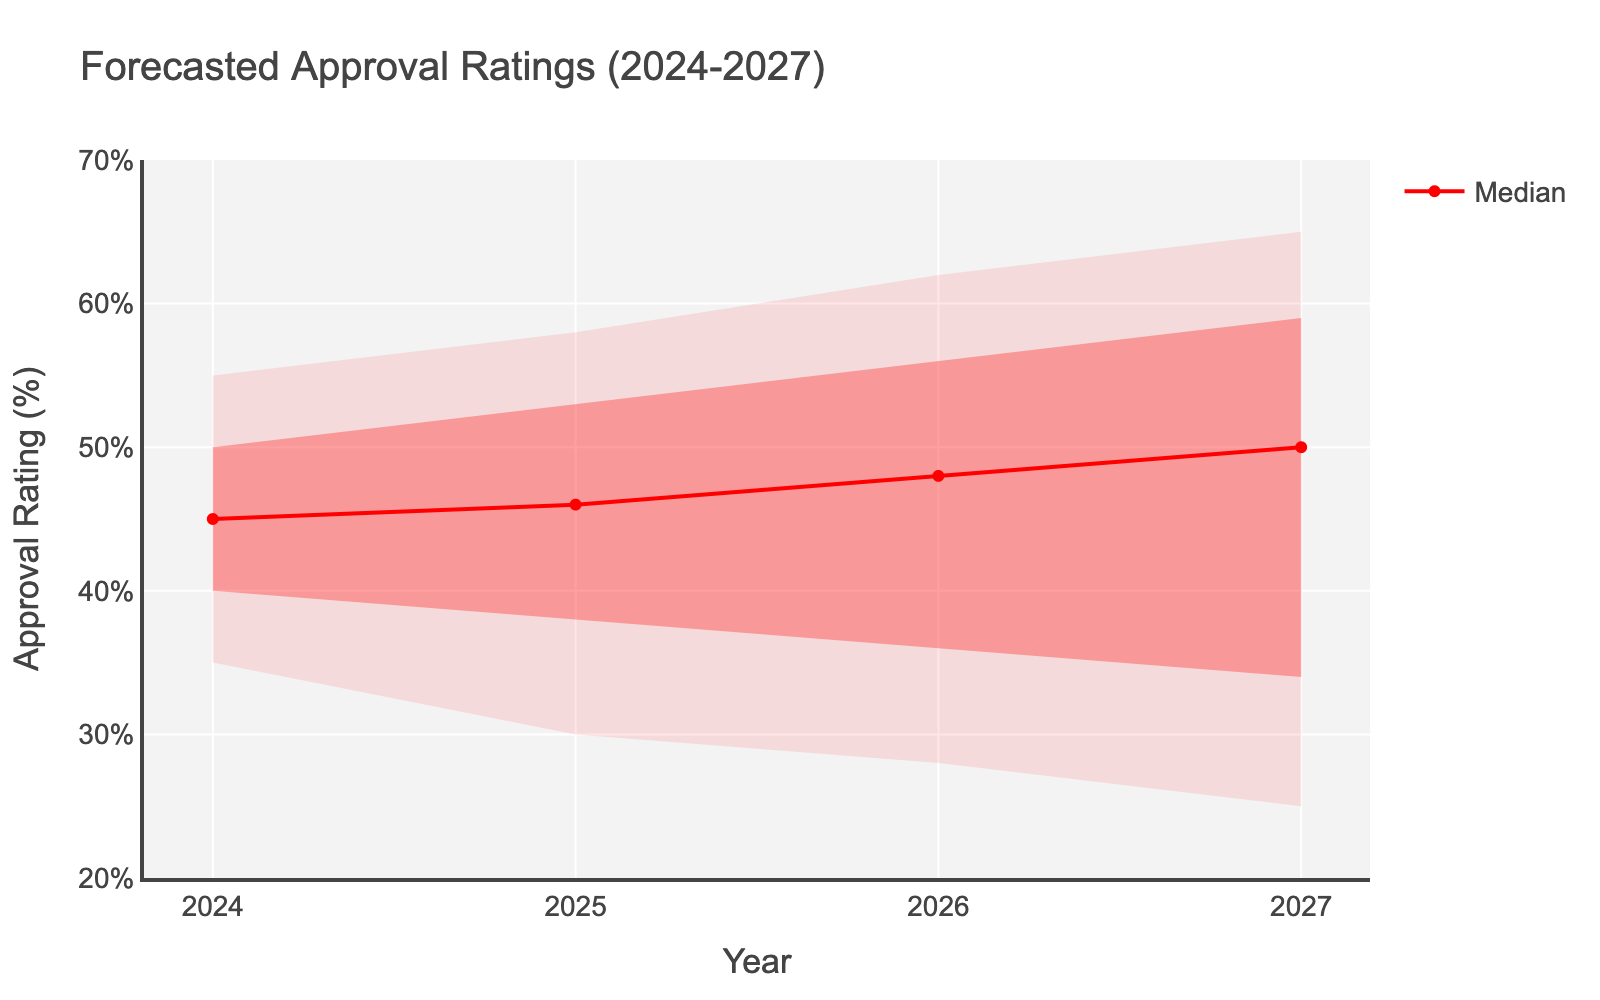What is the title of the figure? The title is listed at the top center of the chart, indicating the focus of the chart.
Answer: Forecasted Approval Ratings (2024-2027) What is the range of the y-axis? The y-axis is labeled and shows the minimum and maximum values covered by the axis. The range starts at 20% and goes up to 70%.
Answer: 20% to 70% What is the median approval rating forecast for the year 2026? Locate the median value line for 2026 and read the y-axis value corresponding to that point.
Answer: 48% Which year shows the highest lower bound of the 90% confidence interval? Compare the lower bounds (indicated by the shaded areas) over the years 2024 to 2027. The highest lower bound is 35% in 2024.
Answer: 2024 How does the median approval rating change from 2024 to 2025? Subtract the median value of 2024 from the median value of 2025: 46% - 45% = 1% increase.
Answer: Increases by 1% Is the approval rating for the year 2027 more uncertain than 2024? Compare the width of shaded areas representing confidence intervals for both years. Wider shaded areas indicate higher uncertainty.
Answer: Yes What is the range of the 50% confidence interval in 2027? The 50% confidence interval is between the lower 25% and upper 75% bounds. For 2027: 59% - 34% = 25%.
Answer: 34% to 59% How many years does the chart display forecasted ratings for? Count the number of years listed on the x-axis: 2024, 2025, 2026, and 2027.
Answer: Four years What color represents the 90% confidence interval for approval ratings? The 90% confidence interval is shaded and its color can be observed in the lightest-shaded area of the chart.
Answer: Light red Which year's median forecasted approval rating is the highest? Compare the median values across the years; the highest median is 50% in 2027.
Answer: 2027 